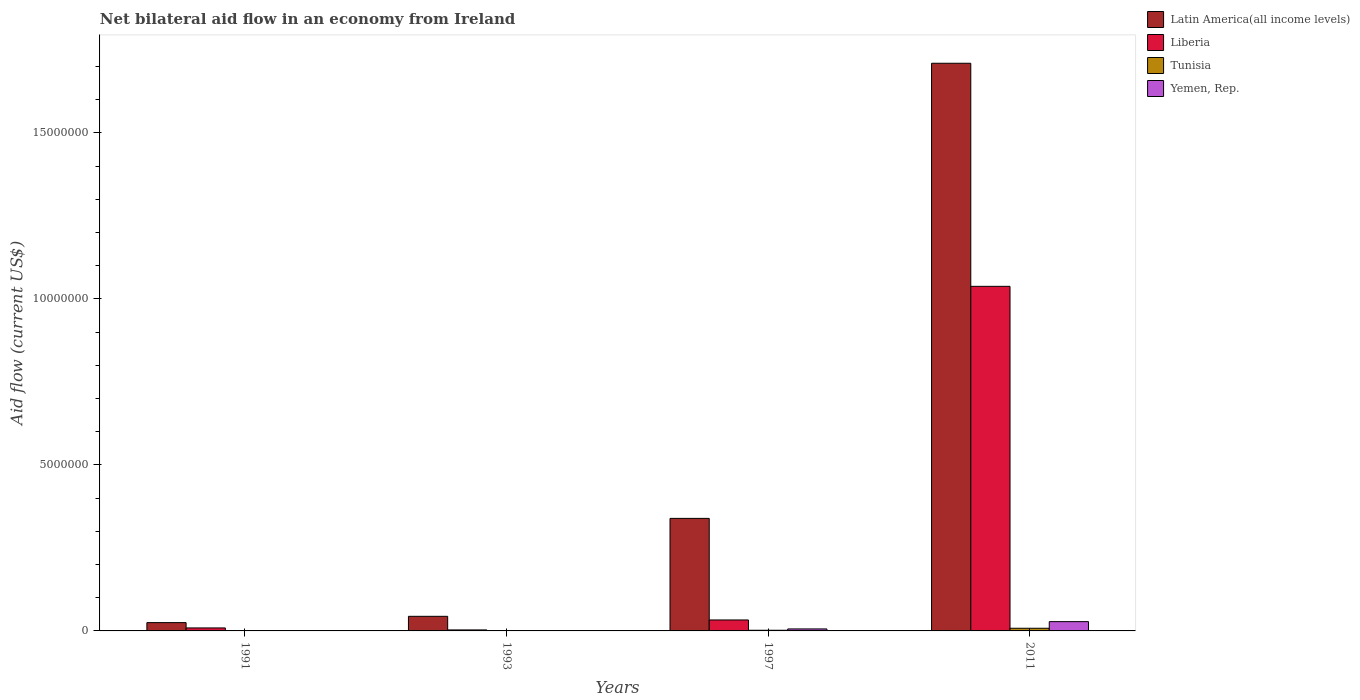Are the number of bars on each tick of the X-axis equal?
Make the answer very short. Yes. How many bars are there on the 1st tick from the left?
Provide a succinct answer. 4. How many bars are there on the 4th tick from the right?
Offer a very short reply. 4. In how many cases, is the number of bars for a given year not equal to the number of legend labels?
Provide a succinct answer. 0. What is the net bilateral aid flow in Latin America(all income levels) in 2011?
Ensure brevity in your answer.  1.71e+07. Across all years, what is the maximum net bilateral aid flow in Latin America(all income levels)?
Provide a short and direct response. 1.71e+07. Across all years, what is the minimum net bilateral aid flow in Latin America(all income levels)?
Ensure brevity in your answer.  2.50e+05. In which year was the net bilateral aid flow in Yemen, Rep. minimum?
Your response must be concise. 1991. What is the total net bilateral aid flow in Latin America(all income levels) in the graph?
Make the answer very short. 2.12e+07. What is the difference between the net bilateral aid flow in Latin America(all income levels) in 1993 and the net bilateral aid flow in Liberia in 1991?
Your response must be concise. 3.50e+05. What is the average net bilateral aid flow in Latin America(all income levels) per year?
Ensure brevity in your answer.  5.30e+06. In the year 1997, what is the difference between the net bilateral aid flow in Tunisia and net bilateral aid flow in Liberia?
Keep it short and to the point. -3.10e+05. In how many years, is the net bilateral aid flow in Tunisia greater than 15000000 US$?
Provide a short and direct response. 0. What is the ratio of the net bilateral aid flow in Tunisia in 1991 to that in 1997?
Your answer should be compact. 0.5. Is the difference between the net bilateral aid flow in Tunisia in 1991 and 1997 greater than the difference between the net bilateral aid flow in Liberia in 1991 and 1997?
Provide a short and direct response. Yes. What is the difference between the highest and the second highest net bilateral aid flow in Tunisia?
Keep it short and to the point. 6.00e+04. Is the sum of the net bilateral aid flow in Liberia in 1991 and 2011 greater than the maximum net bilateral aid flow in Tunisia across all years?
Make the answer very short. Yes. Is it the case that in every year, the sum of the net bilateral aid flow in Latin America(all income levels) and net bilateral aid flow in Yemen, Rep. is greater than the sum of net bilateral aid flow in Liberia and net bilateral aid flow in Tunisia?
Provide a short and direct response. No. What does the 3rd bar from the left in 1997 represents?
Offer a very short reply. Tunisia. What does the 3rd bar from the right in 2011 represents?
Provide a succinct answer. Liberia. Is it the case that in every year, the sum of the net bilateral aid flow in Latin America(all income levels) and net bilateral aid flow in Tunisia is greater than the net bilateral aid flow in Yemen, Rep.?
Offer a terse response. Yes. Are all the bars in the graph horizontal?
Your answer should be compact. No. How many years are there in the graph?
Keep it short and to the point. 4. What is the difference between two consecutive major ticks on the Y-axis?
Make the answer very short. 5.00e+06. Are the values on the major ticks of Y-axis written in scientific E-notation?
Offer a terse response. No. Does the graph contain any zero values?
Make the answer very short. No. Does the graph contain grids?
Offer a very short reply. No. How many legend labels are there?
Make the answer very short. 4. What is the title of the graph?
Your answer should be compact. Net bilateral aid flow in an economy from Ireland. Does "Bosnia and Herzegovina" appear as one of the legend labels in the graph?
Make the answer very short. No. What is the label or title of the X-axis?
Provide a short and direct response. Years. What is the label or title of the Y-axis?
Keep it short and to the point. Aid flow (current US$). What is the Aid flow (current US$) in Latin America(all income levels) in 1991?
Your response must be concise. 2.50e+05. What is the Aid flow (current US$) in Liberia in 1991?
Your answer should be compact. 9.00e+04. What is the Aid flow (current US$) of Tunisia in 1991?
Offer a very short reply. 10000. What is the Aid flow (current US$) in Yemen, Rep. in 1991?
Your answer should be compact. 10000. What is the Aid flow (current US$) in Latin America(all income levels) in 1997?
Ensure brevity in your answer.  3.39e+06. What is the Aid flow (current US$) of Liberia in 1997?
Provide a succinct answer. 3.30e+05. What is the Aid flow (current US$) in Yemen, Rep. in 1997?
Provide a succinct answer. 6.00e+04. What is the Aid flow (current US$) in Latin America(all income levels) in 2011?
Your answer should be compact. 1.71e+07. What is the Aid flow (current US$) in Liberia in 2011?
Your answer should be compact. 1.04e+07. What is the Aid flow (current US$) in Yemen, Rep. in 2011?
Ensure brevity in your answer.  2.80e+05. Across all years, what is the maximum Aid flow (current US$) in Latin America(all income levels)?
Provide a short and direct response. 1.71e+07. Across all years, what is the maximum Aid flow (current US$) in Liberia?
Offer a very short reply. 1.04e+07. Across all years, what is the maximum Aid flow (current US$) in Tunisia?
Provide a short and direct response. 8.00e+04. Across all years, what is the minimum Aid flow (current US$) in Latin America(all income levels)?
Your response must be concise. 2.50e+05. Across all years, what is the minimum Aid flow (current US$) of Liberia?
Offer a terse response. 3.00e+04. Across all years, what is the minimum Aid flow (current US$) in Tunisia?
Offer a very short reply. 10000. Across all years, what is the minimum Aid flow (current US$) in Yemen, Rep.?
Provide a succinct answer. 10000. What is the total Aid flow (current US$) in Latin America(all income levels) in the graph?
Provide a short and direct response. 2.12e+07. What is the total Aid flow (current US$) in Liberia in the graph?
Provide a succinct answer. 1.08e+07. What is the difference between the Aid flow (current US$) in Latin America(all income levels) in 1991 and that in 1997?
Give a very brief answer. -3.14e+06. What is the difference between the Aid flow (current US$) of Liberia in 1991 and that in 1997?
Keep it short and to the point. -2.40e+05. What is the difference between the Aid flow (current US$) of Tunisia in 1991 and that in 1997?
Provide a succinct answer. -10000. What is the difference between the Aid flow (current US$) of Yemen, Rep. in 1991 and that in 1997?
Make the answer very short. -5.00e+04. What is the difference between the Aid flow (current US$) in Latin America(all income levels) in 1991 and that in 2011?
Offer a terse response. -1.68e+07. What is the difference between the Aid flow (current US$) of Liberia in 1991 and that in 2011?
Your response must be concise. -1.03e+07. What is the difference between the Aid flow (current US$) of Tunisia in 1991 and that in 2011?
Your answer should be very brief. -7.00e+04. What is the difference between the Aid flow (current US$) of Latin America(all income levels) in 1993 and that in 1997?
Your answer should be compact. -2.95e+06. What is the difference between the Aid flow (current US$) of Yemen, Rep. in 1993 and that in 1997?
Offer a very short reply. -5.00e+04. What is the difference between the Aid flow (current US$) in Latin America(all income levels) in 1993 and that in 2011?
Provide a short and direct response. -1.67e+07. What is the difference between the Aid flow (current US$) of Liberia in 1993 and that in 2011?
Make the answer very short. -1.04e+07. What is the difference between the Aid flow (current US$) in Latin America(all income levels) in 1997 and that in 2011?
Your answer should be very brief. -1.37e+07. What is the difference between the Aid flow (current US$) of Liberia in 1997 and that in 2011?
Your answer should be compact. -1.00e+07. What is the difference between the Aid flow (current US$) in Latin America(all income levels) in 1991 and the Aid flow (current US$) in Liberia in 1993?
Keep it short and to the point. 2.20e+05. What is the difference between the Aid flow (current US$) in Latin America(all income levels) in 1991 and the Aid flow (current US$) in Tunisia in 1993?
Your answer should be very brief. 2.40e+05. What is the difference between the Aid flow (current US$) in Latin America(all income levels) in 1991 and the Aid flow (current US$) in Liberia in 2011?
Keep it short and to the point. -1.01e+07. What is the difference between the Aid flow (current US$) in Tunisia in 1991 and the Aid flow (current US$) in Yemen, Rep. in 2011?
Offer a terse response. -2.70e+05. What is the difference between the Aid flow (current US$) in Latin America(all income levels) in 1993 and the Aid flow (current US$) in Liberia in 1997?
Give a very brief answer. 1.10e+05. What is the difference between the Aid flow (current US$) of Latin America(all income levels) in 1993 and the Aid flow (current US$) of Tunisia in 1997?
Give a very brief answer. 4.20e+05. What is the difference between the Aid flow (current US$) in Latin America(all income levels) in 1993 and the Aid flow (current US$) in Liberia in 2011?
Your answer should be very brief. -9.94e+06. What is the difference between the Aid flow (current US$) of Latin America(all income levels) in 1993 and the Aid flow (current US$) of Tunisia in 2011?
Ensure brevity in your answer.  3.60e+05. What is the difference between the Aid flow (current US$) of Latin America(all income levels) in 1993 and the Aid flow (current US$) of Yemen, Rep. in 2011?
Ensure brevity in your answer.  1.60e+05. What is the difference between the Aid flow (current US$) in Tunisia in 1993 and the Aid flow (current US$) in Yemen, Rep. in 2011?
Keep it short and to the point. -2.70e+05. What is the difference between the Aid flow (current US$) of Latin America(all income levels) in 1997 and the Aid flow (current US$) of Liberia in 2011?
Give a very brief answer. -6.99e+06. What is the difference between the Aid flow (current US$) in Latin America(all income levels) in 1997 and the Aid flow (current US$) in Tunisia in 2011?
Provide a succinct answer. 3.31e+06. What is the difference between the Aid flow (current US$) in Latin America(all income levels) in 1997 and the Aid flow (current US$) in Yemen, Rep. in 2011?
Offer a terse response. 3.11e+06. What is the difference between the Aid flow (current US$) of Liberia in 1997 and the Aid flow (current US$) of Yemen, Rep. in 2011?
Ensure brevity in your answer.  5.00e+04. What is the average Aid flow (current US$) of Latin America(all income levels) per year?
Provide a succinct answer. 5.30e+06. What is the average Aid flow (current US$) of Liberia per year?
Your answer should be very brief. 2.71e+06. What is the average Aid flow (current US$) in Yemen, Rep. per year?
Keep it short and to the point. 9.00e+04. In the year 1991, what is the difference between the Aid flow (current US$) of Latin America(all income levels) and Aid flow (current US$) of Liberia?
Your answer should be compact. 1.60e+05. In the year 1991, what is the difference between the Aid flow (current US$) of Latin America(all income levels) and Aid flow (current US$) of Yemen, Rep.?
Give a very brief answer. 2.40e+05. In the year 1991, what is the difference between the Aid flow (current US$) in Tunisia and Aid flow (current US$) in Yemen, Rep.?
Your response must be concise. 0. In the year 1993, what is the difference between the Aid flow (current US$) in Liberia and Aid flow (current US$) in Tunisia?
Your answer should be very brief. 2.00e+04. In the year 1993, what is the difference between the Aid flow (current US$) in Liberia and Aid flow (current US$) in Yemen, Rep.?
Provide a short and direct response. 2.00e+04. In the year 1997, what is the difference between the Aid flow (current US$) in Latin America(all income levels) and Aid flow (current US$) in Liberia?
Provide a succinct answer. 3.06e+06. In the year 1997, what is the difference between the Aid flow (current US$) of Latin America(all income levels) and Aid flow (current US$) of Tunisia?
Ensure brevity in your answer.  3.37e+06. In the year 1997, what is the difference between the Aid flow (current US$) in Latin America(all income levels) and Aid flow (current US$) in Yemen, Rep.?
Offer a very short reply. 3.33e+06. In the year 1997, what is the difference between the Aid flow (current US$) in Liberia and Aid flow (current US$) in Yemen, Rep.?
Ensure brevity in your answer.  2.70e+05. In the year 2011, what is the difference between the Aid flow (current US$) in Latin America(all income levels) and Aid flow (current US$) in Liberia?
Your answer should be compact. 6.72e+06. In the year 2011, what is the difference between the Aid flow (current US$) in Latin America(all income levels) and Aid flow (current US$) in Tunisia?
Give a very brief answer. 1.70e+07. In the year 2011, what is the difference between the Aid flow (current US$) in Latin America(all income levels) and Aid flow (current US$) in Yemen, Rep.?
Ensure brevity in your answer.  1.68e+07. In the year 2011, what is the difference between the Aid flow (current US$) of Liberia and Aid flow (current US$) of Tunisia?
Offer a terse response. 1.03e+07. In the year 2011, what is the difference between the Aid flow (current US$) of Liberia and Aid flow (current US$) of Yemen, Rep.?
Provide a short and direct response. 1.01e+07. What is the ratio of the Aid flow (current US$) in Latin America(all income levels) in 1991 to that in 1993?
Provide a short and direct response. 0.57. What is the ratio of the Aid flow (current US$) in Liberia in 1991 to that in 1993?
Provide a short and direct response. 3. What is the ratio of the Aid flow (current US$) of Tunisia in 1991 to that in 1993?
Keep it short and to the point. 1. What is the ratio of the Aid flow (current US$) of Yemen, Rep. in 1991 to that in 1993?
Give a very brief answer. 1. What is the ratio of the Aid flow (current US$) in Latin America(all income levels) in 1991 to that in 1997?
Give a very brief answer. 0.07. What is the ratio of the Aid flow (current US$) in Liberia in 1991 to that in 1997?
Provide a short and direct response. 0.27. What is the ratio of the Aid flow (current US$) in Tunisia in 1991 to that in 1997?
Provide a short and direct response. 0.5. What is the ratio of the Aid flow (current US$) of Yemen, Rep. in 1991 to that in 1997?
Your response must be concise. 0.17. What is the ratio of the Aid flow (current US$) in Latin America(all income levels) in 1991 to that in 2011?
Provide a succinct answer. 0.01. What is the ratio of the Aid flow (current US$) in Liberia in 1991 to that in 2011?
Provide a short and direct response. 0.01. What is the ratio of the Aid flow (current US$) in Tunisia in 1991 to that in 2011?
Your answer should be compact. 0.12. What is the ratio of the Aid flow (current US$) of Yemen, Rep. in 1991 to that in 2011?
Give a very brief answer. 0.04. What is the ratio of the Aid flow (current US$) in Latin America(all income levels) in 1993 to that in 1997?
Your answer should be compact. 0.13. What is the ratio of the Aid flow (current US$) in Liberia in 1993 to that in 1997?
Make the answer very short. 0.09. What is the ratio of the Aid flow (current US$) of Tunisia in 1993 to that in 1997?
Offer a terse response. 0.5. What is the ratio of the Aid flow (current US$) in Yemen, Rep. in 1993 to that in 1997?
Offer a very short reply. 0.17. What is the ratio of the Aid flow (current US$) of Latin America(all income levels) in 1993 to that in 2011?
Your answer should be compact. 0.03. What is the ratio of the Aid flow (current US$) of Liberia in 1993 to that in 2011?
Offer a very short reply. 0. What is the ratio of the Aid flow (current US$) in Tunisia in 1993 to that in 2011?
Give a very brief answer. 0.12. What is the ratio of the Aid flow (current US$) of Yemen, Rep. in 1993 to that in 2011?
Give a very brief answer. 0.04. What is the ratio of the Aid flow (current US$) of Latin America(all income levels) in 1997 to that in 2011?
Ensure brevity in your answer.  0.2. What is the ratio of the Aid flow (current US$) in Liberia in 1997 to that in 2011?
Ensure brevity in your answer.  0.03. What is the ratio of the Aid flow (current US$) of Yemen, Rep. in 1997 to that in 2011?
Offer a terse response. 0.21. What is the difference between the highest and the second highest Aid flow (current US$) of Latin America(all income levels)?
Your answer should be compact. 1.37e+07. What is the difference between the highest and the second highest Aid flow (current US$) of Liberia?
Offer a terse response. 1.00e+07. What is the difference between the highest and the second highest Aid flow (current US$) in Tunisia?
Offer a terse response. 6.00e+04. What is the difference between the highest and the second highest Aid flow (current US$) of Yemen, Rep.?
Your response must be concise. 2.20e+05. What is the difference between the highest and the lowest Aid flow (current US$) of Latin America(all income levels)?
Offer a terse response. 1.68e+07. What is the difference between the highest and the lowest Aid flow (current US$) in Liberia?
Make the answer very short. 1.04e+07. What is the difference between the highest and the lowest Aid flow (current US$) in Yemen, Rep.?
Make the answer very short. 2.70e+05. 